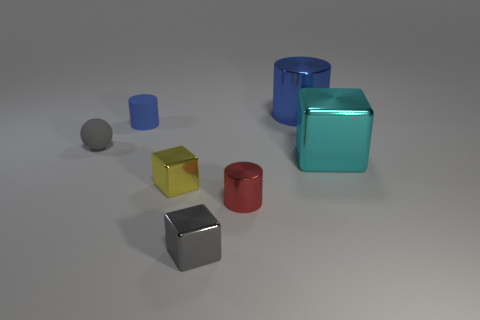Add 1 tiny cyan matte objects. How many objects exist? 8 Subtract all cylinders. How many objects are left? 4 Subtract 0 purple spheres. How many objects are left? 7 Subtract all blue metal things. Subtract all large blue metal cylinders. How many objects are left? 5 Add 4 tiny blue rubber objects. How many tiny blue rubber objects are left? 5 Add 6 big yellow matte cubes. How many big yellow matte cubes exist? 6 